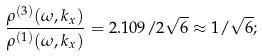<formula> <loc_0><loc_0><loc_500><loc_500>\frac { \rho ^ { ( 3 ) } ( \omega , k _ { x } ) } { \rho ^ { ( 1 ) } ( \omega , k _ { x } ) } = 2 . 1 0 9 / 2 \sqrt { 6 } \approx 1 / \sqrt { 6 } ;</formula> 